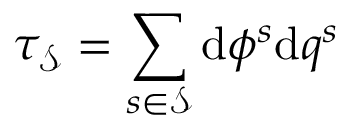Convert formula to latex. <formula><loc_0><loc_0><loc_500><loc_500>\tau _ { \mathcal { S } } = \sum _ { s \in \mathcal { S } } d \phi ^ { s } d q ^ { s }</formula> 